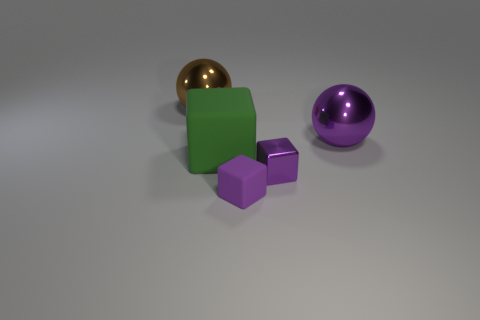What can you tell me about the lighting in the scene? The scene is illuminated with diffuse overhead lighting, casting soft shadows beneath each object, giving the impression of a natural light source that's neither overly harsh nor too dim. Does the image give any clues about the setting or context? The image lacks distinct background elements and is set against a neutral gray backdrop, suggesting it may be a controlled environment such as a studio setup designed to focus attention solely on the objects. 